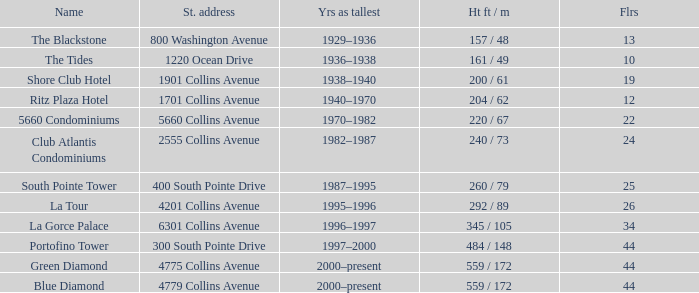What is the height of the Tides with less than 34 floors? 161 / 49. 